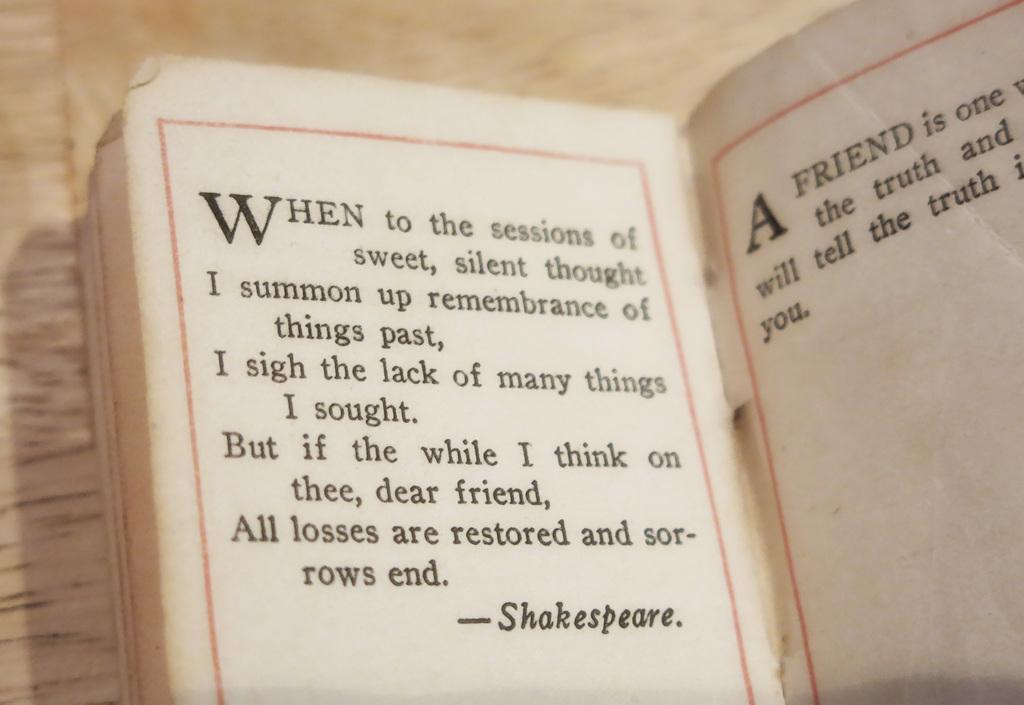What is the first word on the first page?
Make the answer very short. When. Who is the author of this piece of literature?
Provide a succinct answer. Shakespeare. 